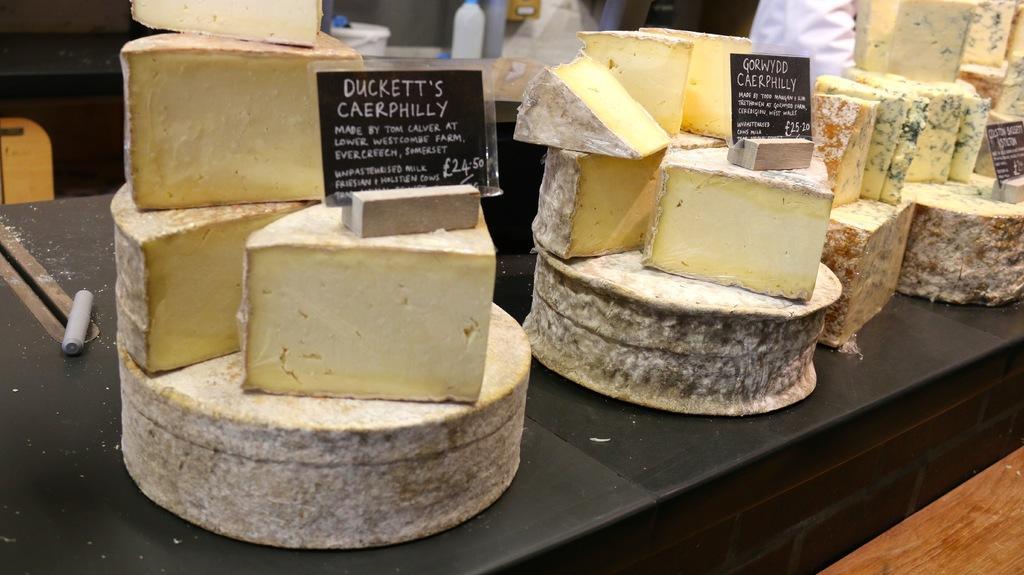Describe this image in one or two sentences. In this image we can see some food items on the black colored surface, there an object on it, there are boards with some text on it, there are bottles on the other table, there is a wooden table. 